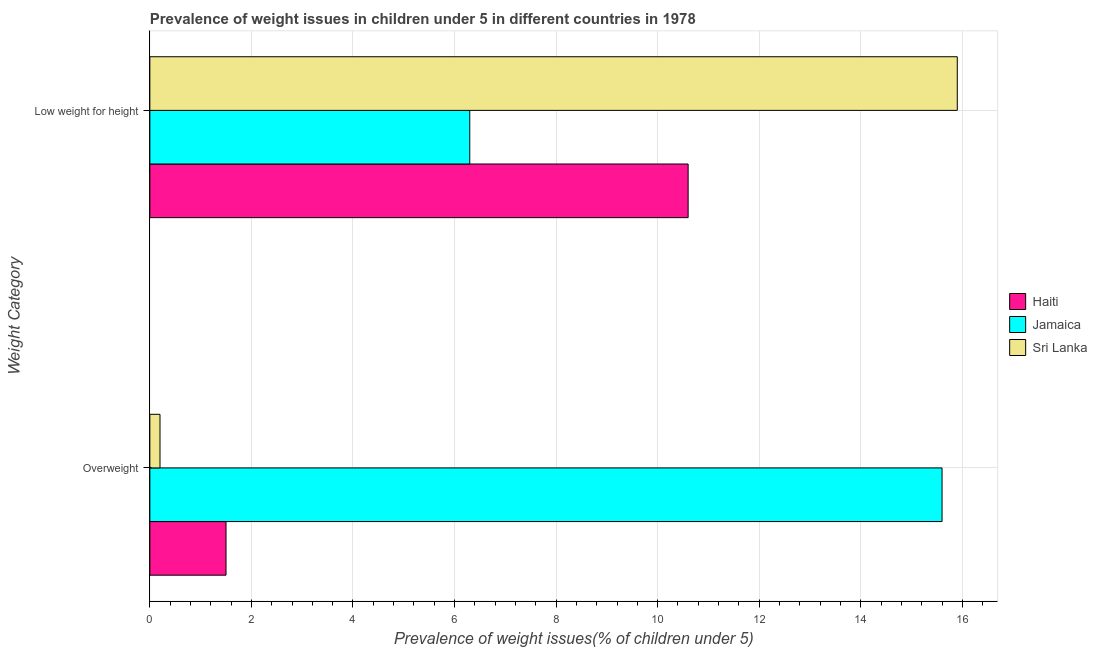How many groups of bars are there?
Offer a very short reply. 2. Are the number of bars on each tick of the Y-axis equal?
Your answer should be compact. Yes. How many bars are there on the 1st tick from the bottom?
Make the answer very short. 3. What is the label of the 2nd group of bars from the top?
Keep it short and to the point. Overweight. What is the percentage of overweight children in Sri Lanka?
Your answer should be compact. 0.2. Across all countries, what is the maximum percentage of underweight children?
Provide a short and direct response. 15.9. Across all countries, what is the minimum percentage of underweight children?
Your answer should be compact. 6.3. In which country was the percentage of overweight children maximum?
Keep it short and to the point. Jamaica. In which country was the percentage of overweight children minimum?
Ensure brevity in your answer.  Sri Lanka. What is the total percentage of underweight children in the graph?
Provide a succinct answer. 32.8. What is the difference between the percentage of overweight children in Haiti and that in Jamaica?
Your answer should be very brief. -14.1. What is the difference between the percentage of underweight children in Haiti and the percentage of overweight children in Sri Lanka?
Provide a short and direct response. 10.4. What is the average percentage of underweight children per country?
Offer a terse response. 10.93. What is the difference between the percentage of underweight children and percentage of overweight children in Jamaica?
Give a very brief answer. -9.3. In how many countries, is the percentage of underweight children greater than 7.6 %?
Offer a very short reply. 2. What is the ratio of the percentage of overweight children in Jamaica to that in Sri Lanka?
Ensure brevity in your answer.  78. Is the percentage of underweight children in Haiti less than that in Sri Lanka?
Provide a succinct answer. Yes. In how many countries, is the percentage of overweight children greater than the average percentage of overweight children taken over all countries?
Give a very brief answer. 1. What does the 3rd bar from the top in Low weight for height represents?
Provide a succinct answer. Haiti. What does the 1st bar from the bottom in Low weight for height represents?
Your answer should be very brief. Haiti. How many bars are there?
Your answer should be compact. 6. What is the difference between two consecutive major ticks on the X-axis?
Give a very brief answer. 2. Does the graph contain grids?
Your response must be concise. Yes. Where does the legend appear in the graph?
Give a very brief answer. Center right. What is the title of the graph?
Your answer should be very brief. Prevalence of weight issues in children under 5 in different countries in 1978. Does "Congo (Democratic)" appear as one of the legend labels in the graph?
Your answer should be very brief. No. What is the label or title of the X-axis?
Provide a short and direct response. Prevalence of weight issues(% of children under 5). What is the label or title of the Y-axis?
Keep it short and to the point. Weight Category. What is the Prevalence of weight issues(% of children under 5) of Haiti in Overweight?
Provide a succinct answer. 1.5. What is the Prevalence of weight issues(% of children under 5) of Jamaica in Overweight?
Ensure brevity in your answer.  15.6. What is the Prevalence of weight issues(% of children under 5) in Sri Lanka in Overweight?
Provide a short and direct response. 0.2. What is the Prevalence of weight issues(% of children under 5) in Haiti in Low weight for height?
Keep it short and to the point. 10.6. What is the Prevalence of weight issues(% of children under 5) in Jamaica in Low weight for height?
Ensure brevity in your answer.  6.3. What is the Prevalence of weight issues(% of children under 5) of Sri Lanka in Low weight for height?
Your answer should be compact. 15.9. Across all Weight Category, what is the maximum Prevalence of weight issues(% of children under 5) of Haiti?
Your response must be concise. 10.6. Across all Weight Category, what is the maximum Prevalence of weight issues(% of children under 5) of Jamaica?
Your answer should be compact. 15.6. Across all Weight Category, what is the maximum Prevalence of weight issues(% of children under 5) in Sri Lanka?
Your answer should be very brief. 15.9. Across all Weight Category, what is the minimum Prevalence of weight issues(% of children under 5) in Jamaica?
Provide a short and direct response. 6.3. Across all Weight Category, what is the minimum Prevalence of weight issues(% of children under 5) of Sri Lanka?
Provide a succinct answer. 0.2. What is the total Prevalence of weight issues(% of children under 5) in Haiti in the graph?
Give a very brief answer. 12.1. What is the total Prevalence of weight issues(% of children under 5) of Jamaica in the graph?
Your response must be concise. 21.9. What is the total Prevalence of weight issues(% of children under 5) of Sri Lanka in the graph?
Your answer should be compact. 16.1. What is the difference between the Prevalence of weight issues(% of children under 5) in Sri Lanka in Overweight and that in Low weight for height?
Offer a very short reply. -15.7. What is the difference between the Prevalence of weight issues(% of children under 5) of Haiti in Overweight and the Prevalence of weight issues(% of children under 5) of Sri Lanka in Low weight for height?
Make the answer very short. -14.4. What is the difference between the Prevalence of weight issues(% of children under 5) in Jamaica in Overweight and the Prevalence of weight issues(% of children under 5) in Sri Lanka in Low weight for height?
Provide a short and direct response. -0.3. What is the average Prevalence of weight issues(% of children under 5) of Haiti per Weight Category?
Offer a terse response. 6.05. What is the average Prevalence of weight issues(% of children under 5) in Jamaica per Weight Category?
Offer a very short reply. 10.95. What is the average Prevalence of weight issues(% of children under 5) in Sri Lanka per Weight Category?
Make the answer very short. 8.05. What is the difference between the Prevalence of weight issues(% of children under 5) in Haiti and Prevalence of weight issues(% of children under 5) in Jamaica in Overweight?
Give a very brief answer. -14.1. What is the difference between the Prevalence of weight issues(% of children under 5) in Haiti and Prevalence of weight issues(% of children under 5) in Sri Lanka in Overweight?
Ensure brevity in your answer.  1.3. What is the difference between the Prevalence of weight issues(% of children under 5) of Jamaica and Prevalence of weight issues(% of children under 5) of Sri Lanka in Overweight?
Make the answer very short. 15.4. What is the difference between the Prevalence of weight issues(% of children under 5) in Haiti and Prevalence of weight issues(% of children under 5) in Jamaica in Low weight for height?
Offer a very short reply. 4.3. What is the ratio of the Prevalence of weight issues(% of children under 5) in Haiti in Overweight to that in Low weight for height?
Provide a succinct answer. 0.14. What is the ratio of the Prevalence of weight issues(% of children under 5) of Jamaica in Overweight to that in Low weight for height?
Provide a short and direct response. 2.48. What is the ratio of the Prevalence of weight issues(% of children under 5) of Sri Lanka in Overweight to that in Low weight for height?
Ensure brevity in your answer.  0.01. What is the difference between the highest and the second highest Prevalence of weight issues(% of children under 5) in Haiti?
Make the answer very short. 9.1. What is the difference between the highest and the second highest Prevalence of weight issues(% of children under 5) of Jamaica?
Your answer should be compact. 9.3. What is the difference between the highest and the second highest Prevalence of weight issues(% of children under 5) in Sri Lanka?
Offer a terse response. 15.7. What is the difference between the highest and the lowest Prevalence of weight issues(% of children under 5) of Haiti?
Make the answer very short. 9.1. What is the difference between the highest and the lowest Prevalence of weight issues(% of children under 5) of Jamaica?
Ensure brevity in your answer.  9.3. 